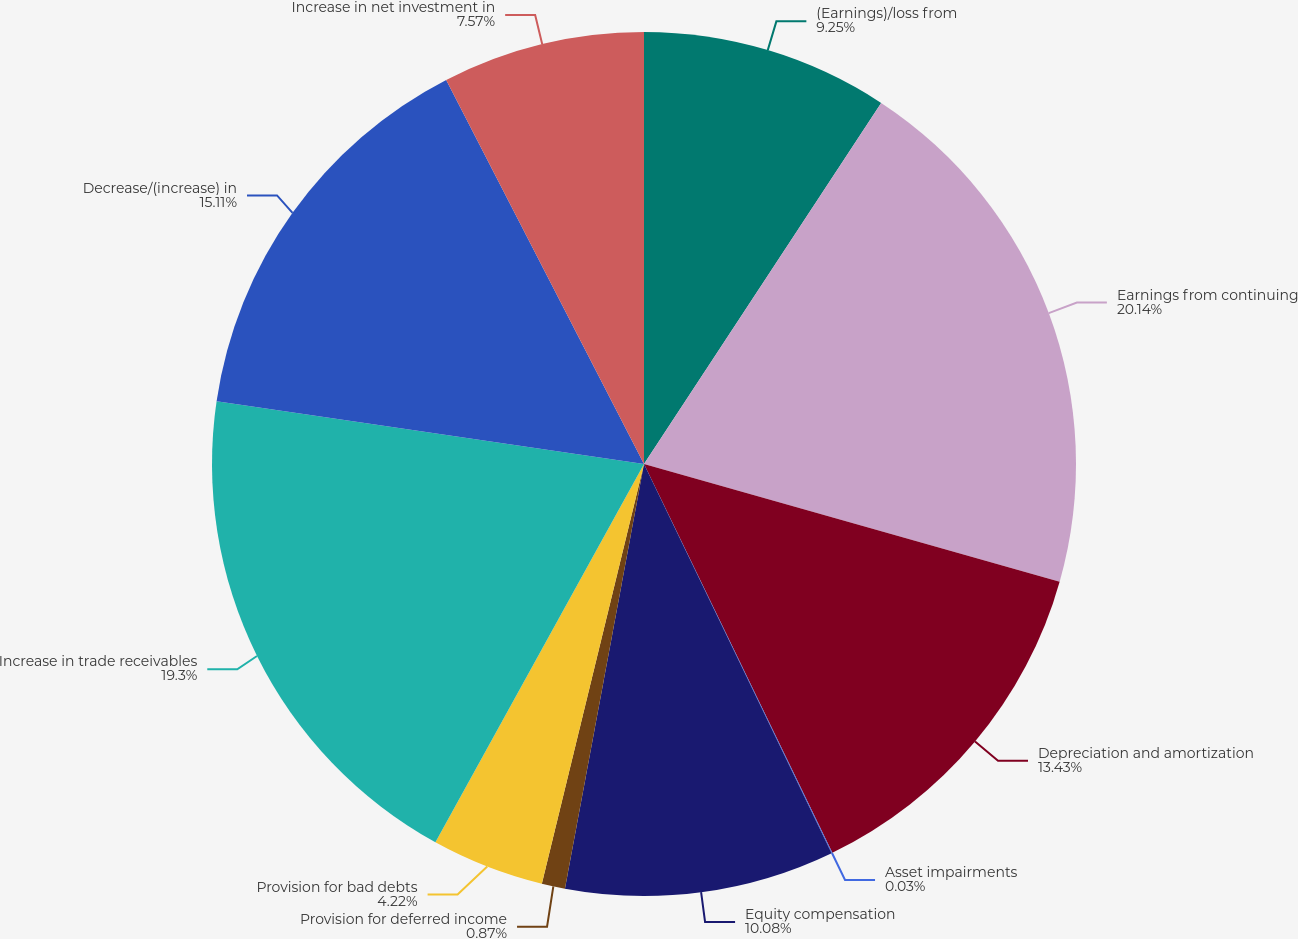Convert chart to OTSL. <chart><loc_0><loc_0><loc_500><loc_500><pie_chart><fcel>(Earnings)/loss from<fcel>Earnings from continuing<fcel>Depreciation and amortization<fcel>Asset impairments<fcel>Equity compensation<fcel>Provision for deferred income<fcel>Provision for bad debts<fcel>Increase in trade receivables<fcel>Decrease/(increase) in<fcel>Increase in net investment in<nl><fcel>9.25%<fcel>20.14%<fcel>13.43%<fcel>0.03%<fcel>10.08%<fcel>0.87%<fcel>4.22%<fcel>19.3%<fcel>15.11%<fcel>7.57%<nl></chart> 